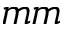<formula> <loc_0><loc_0><loc_500><loc_500>m m</formula> 